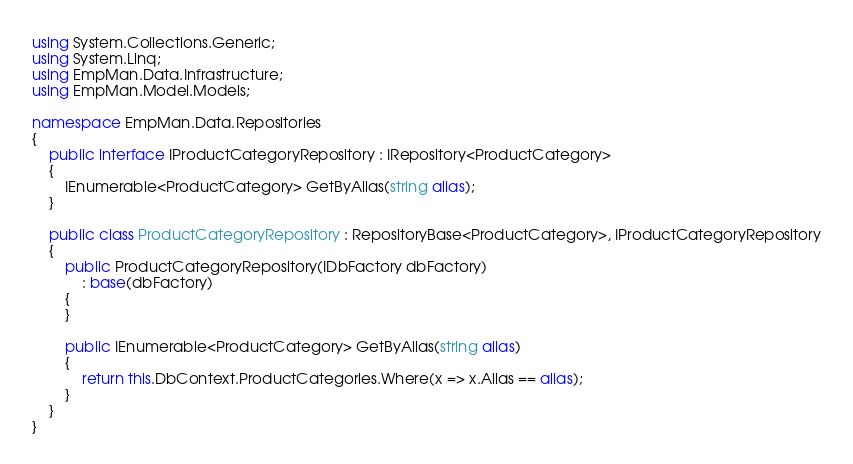<code> <loc_0><loc_0><loc_500><loc_500><_C#_>using System.Collections.Generic;
using System.Linq;
using EmpMan.Data.Infrastructure;
using EmpMan.Model.Models;

namespace EmpMan.Data.Repositories
{
    public interface IProductCategoryRepository : IRepository<ProductCategory>
    {
        IEnumerable<ProductCategory> GetByAlias(string alias);
    }

    public class ProductCategoryRepository : RepositoryBase<ProductCategory>, IProductCategoryRepository
    {
        public ProductCategoryRepository(IDbFactory dbFactory)
            : base(dbFactory)
        {
        }

        public IEnumerable<ProductCategory> GetByAlias(string alias)
        {
            return this.DbContext.ProductCategories.Where(x => x.Alias == alias);
        }
    }
}</code> 